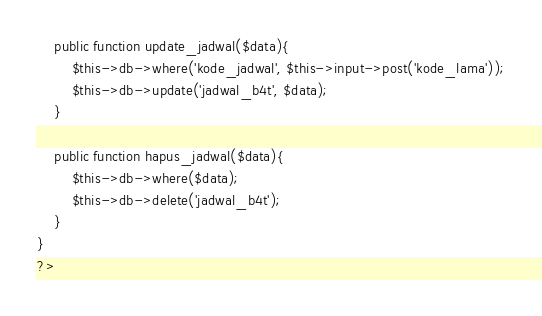<code> <loc_0><loc_0><loc_500><loc_500><_PHP_>
	public function update_jadwal($data){
		$this->db->where('kode_jadwal', $this->input->post('kode_lama'));
		$this->db->update('jadwal_b4t', $data);
	}

	public function hapus_jadwal($data){
		$this->db->where($data);
		$this->db->delete('jadwal_b4t');
	}
}
?></code> 